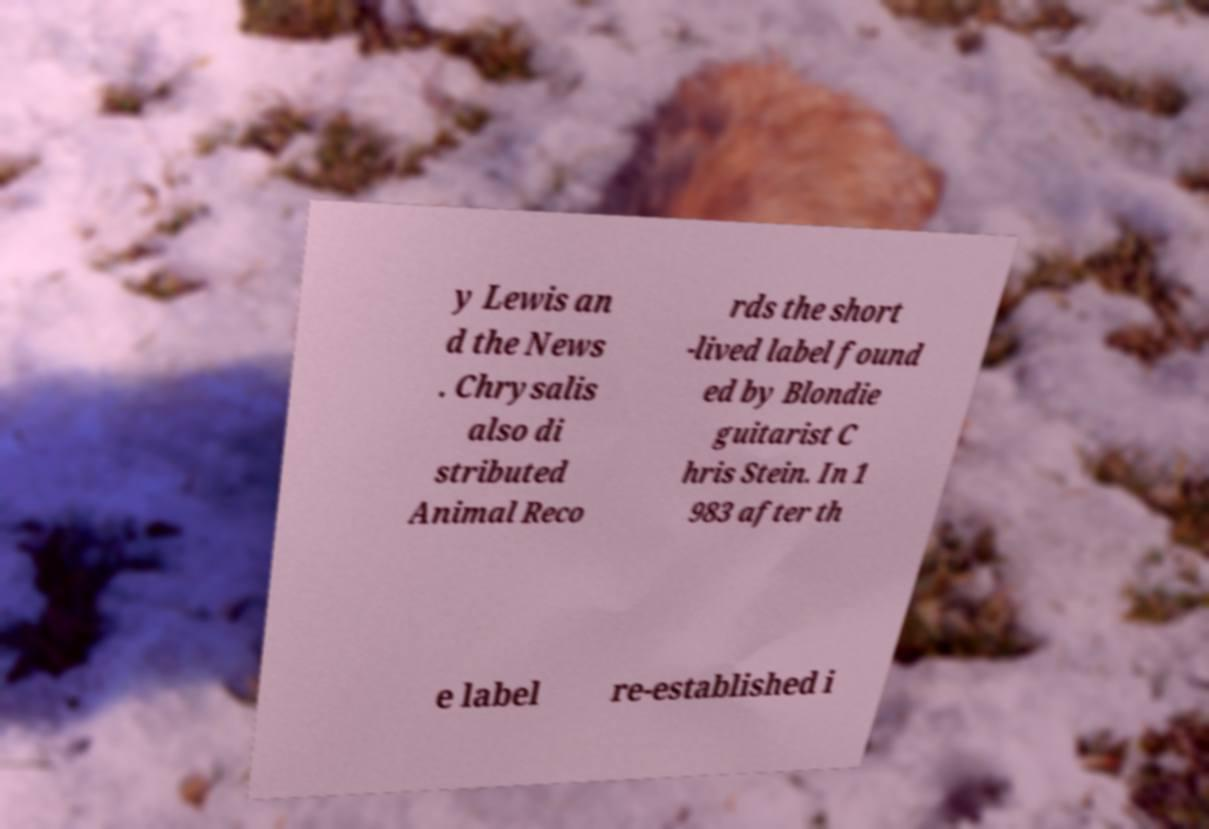Can you accurately transcribe the text from the provided image for me? y Lewis an d the News . Chrysalis also di stributed Animal Reco rds the short -lived label found ed by Blondie guitarist C hris Stein. In 1 983 after th e label re-established i 